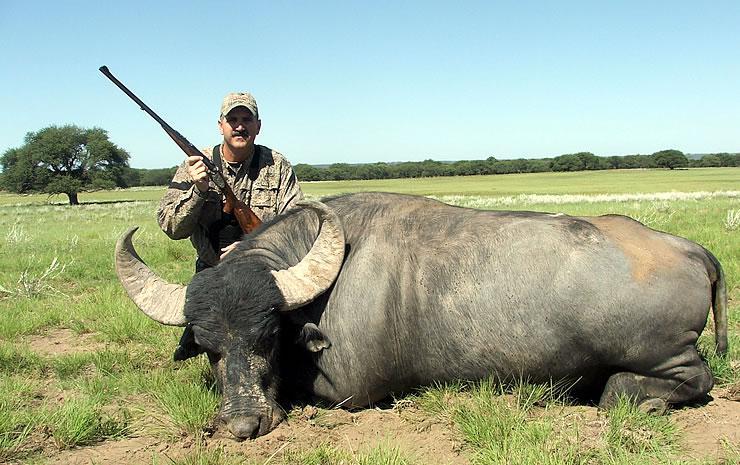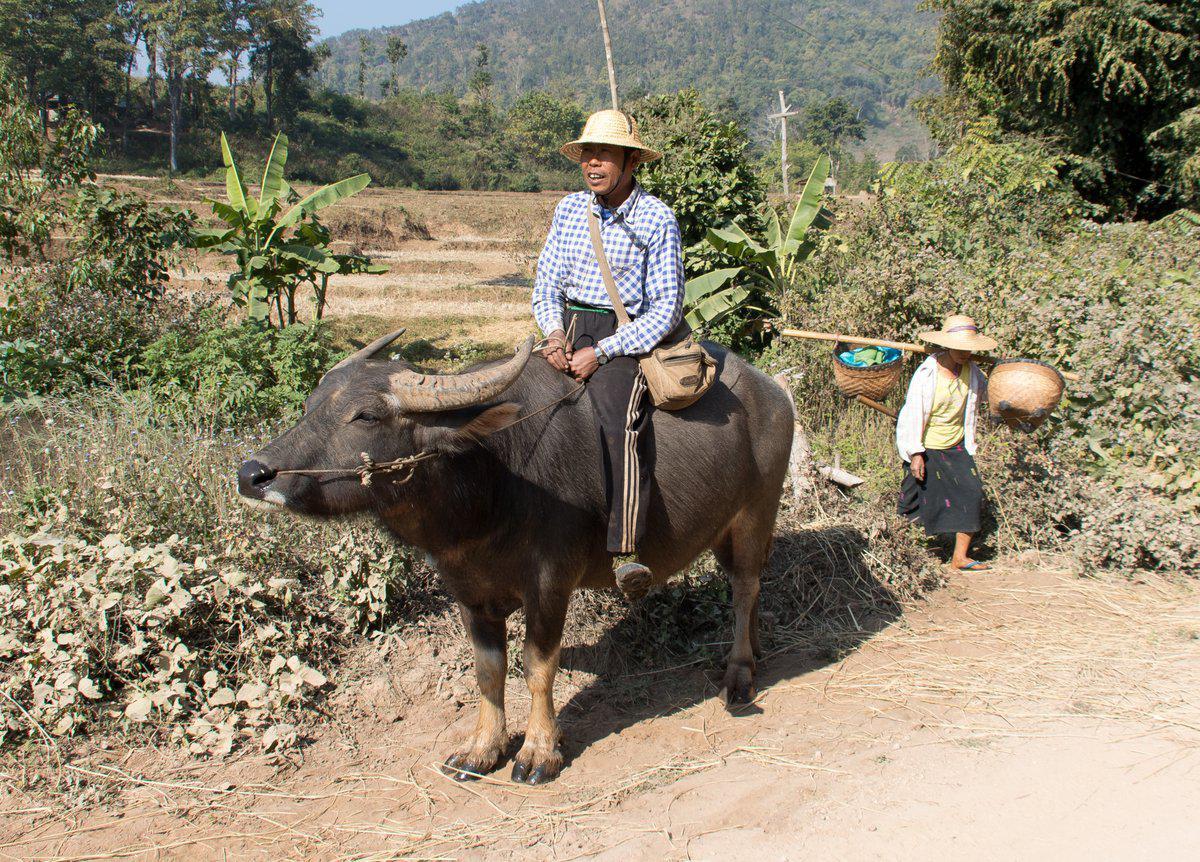The first image is the image on the left, the second image is the image on the right. Given the left and right images, does the statement "The left image contains one hunter near one dead water buffalo." hold true? Answer yes or no. Yes. The first image is the image on the left, the second image is the image on the right. Evaluate the accuracy of this statement regarding the images: "One image shows a man holding a gun posed next to a dead water buffalo, and the other image shows at least one person riding on the back of a water buffalo.". Is it true? Answer yes or no. Yes. 